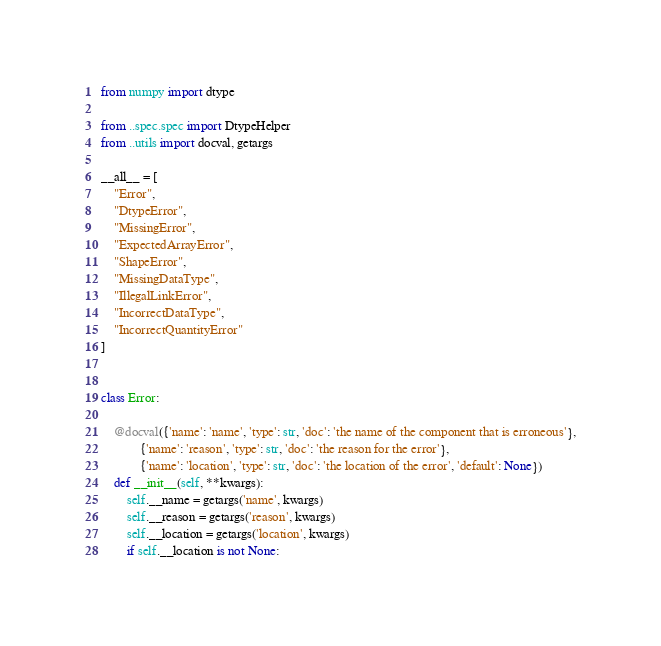<code> <loc_0><loc_0><loc_500><loc_500><_Python_>from numpy import dtype

from ..spec.spec import DtypeHelper
from ..utils import docval, getargs

__all__ = [
    "Error",
    "DtypeError",
    "MissingError",
    "ExpectedArrayError",
    "ShapeError",
    "MissingDataType",
    "IllegalLinkError",
    "IncorrectDataType",
    "IncorrectQuantityError"
]


class Error:

    @docval({'name': 'name', 'type': str, 'doc': 'the name of the component that is erroneous'},
            {'name': 'reason', 'type': str, 'doc': 'the reason for the error'},
            {'name': 'location', 'type': str, 'doc': 'the location of the error', 'default': None})
    def __init__(self, **kwargs):
        self.__name = getargs('name', kwargs)
        self.__reason = getargs('reason', kwargs)
        self.__location = getargs('location', kwargs)
        if self.__location is not None:</code> 